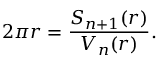<formula> <loc_0><loc_0><loc_500><loc_500>2 \pi r = { \frac { S _ { n + 1 } ( r ) } { V _ { n } ( r ) } } .</formula> 